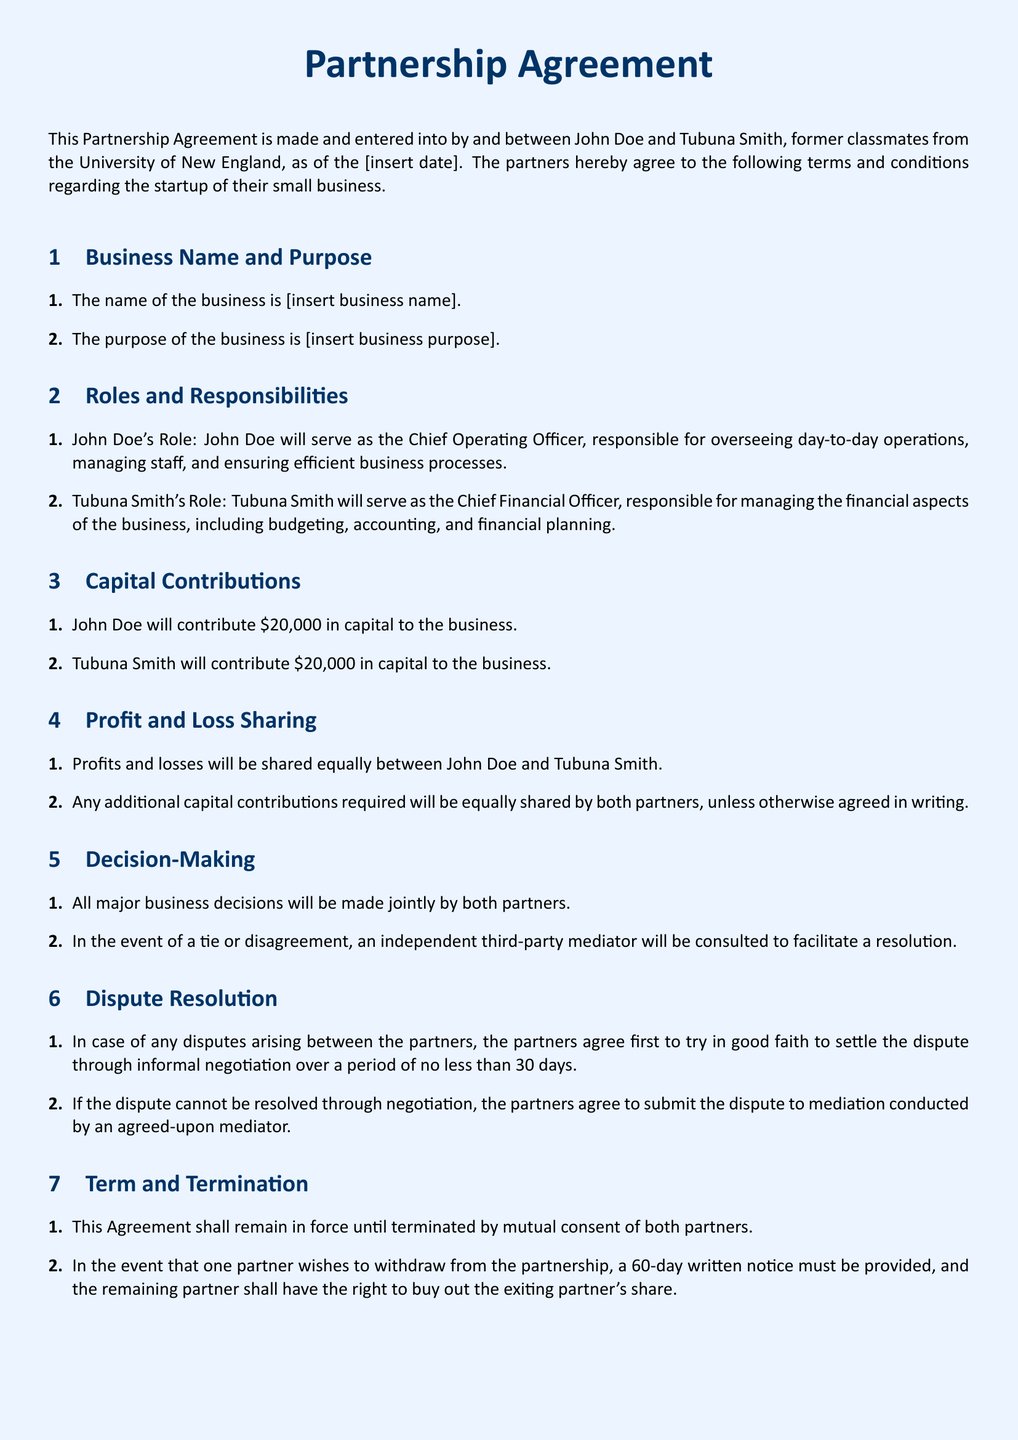What is the business name? The business name is specifically mentioned in the document as [insert business name].
Answer: [insert business name] Who is the Chief Operating Officer? The Chief Operating Officer is the role assigned to John Doe in the agreement.
Answer: John Doe What is Tubuna Smith's capital contribution? The agreement states that Tubuna Smith will contribute $20,000 in capital to the business.
Answer: $20,000 How will profits and losses be shared? The profit and loss sharing clause specifies that profits and losses will be shared equally.
Answer: Equally What happens in the event of a tie in decision-making? The document states that in case of a tie, an independent third-party mediator will be consulted.
Answer: Consult a mediator What is the notice period for withdrawal from the partnership? The agreement specifies a written notice of 60 days must be provided by a partner wishing to withdraw.
Answer: 60 days What will happen if a dispute cannot be resolved through negotiation? The partners agree to submit the dispute to mediation if it cannot be resolved through negotiation.
Answer: Mediation What is required for any changes to the agreement? The agreement states that any changes must be in writing and signed by both partners.
Answer: In writing and signed What constitutes the entire agreement between the partners? The document asserts that it constitutes the entire agreement, superseding prior negotiations.
Answer: Entire agreement 